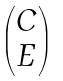<formula> <loc_0><loc_0><loc_500><loc_500>\begin{pmatrix} C \\ E \end{pmatrix}</formula> 